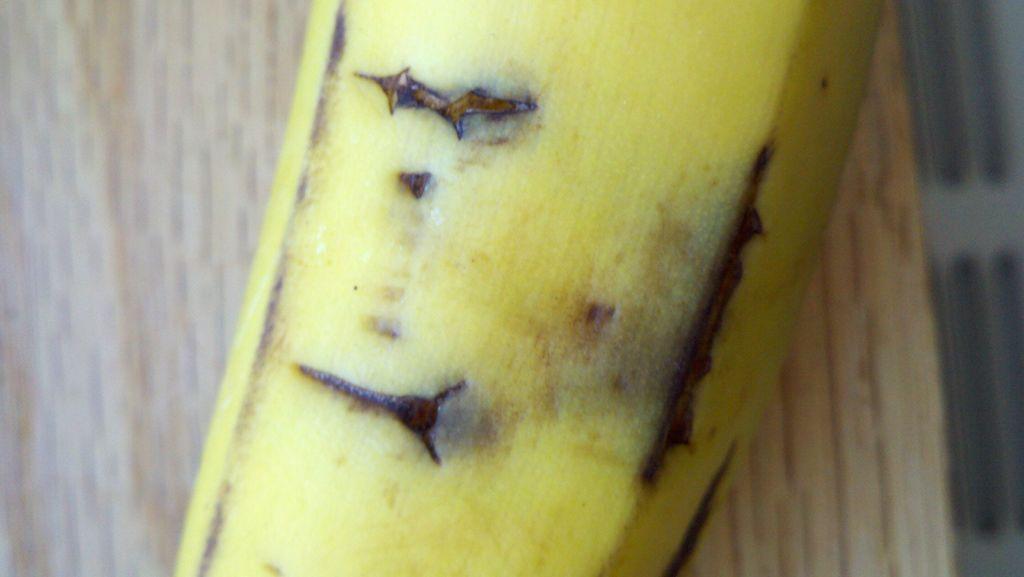Could you give a brief overview of what you see in this image? In the foreground of this image, there is a truncated banana on a wooden surface. 